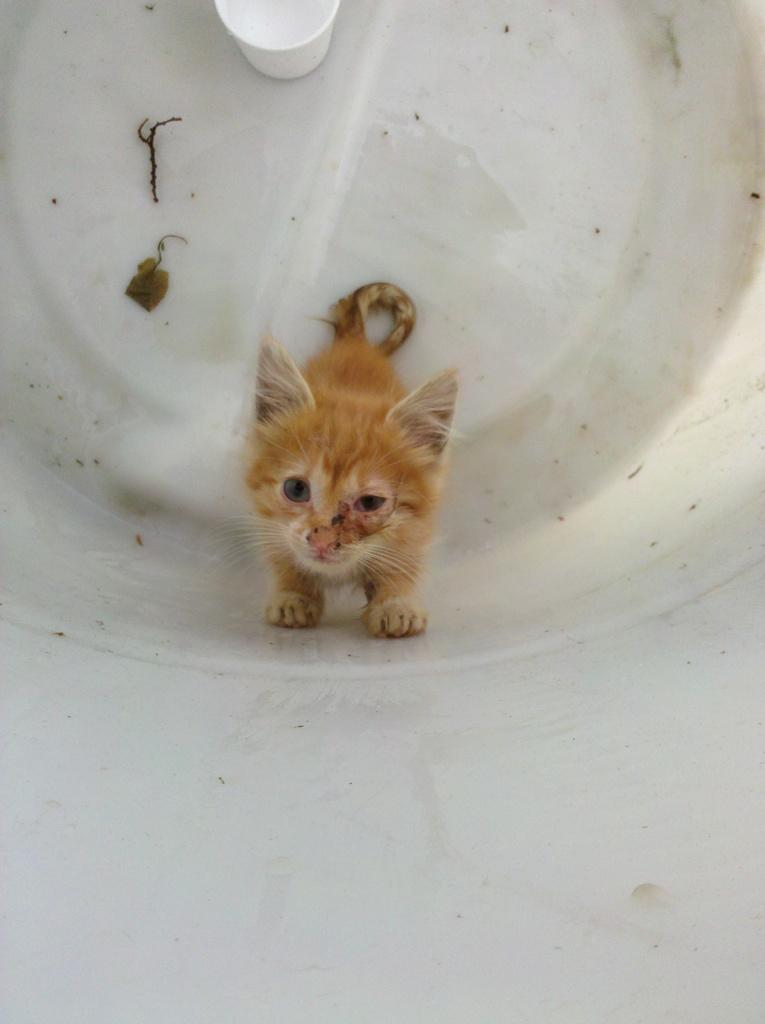What is the main object in the image? There is a small kettle in the image. Where is the kettle located? The kettle is standing in a white pipe. What other object can be seen at the top of the image? There is a cup at the top of the image. How does the kettle help the person in the image breathe easier? There is no person in the image, and the kettle is not related to breathing. 